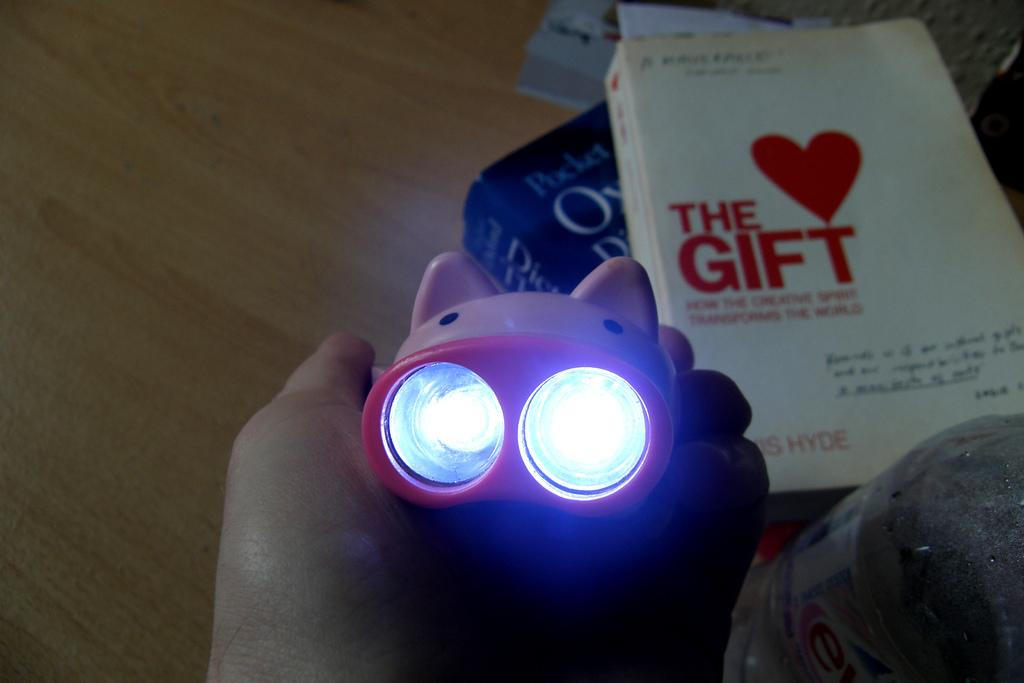What is the main structure in the image? There is a wooden platform in the image. What items are placed on the wooden platform? There are books and a bottle on the wooden platform. What is the person in the image holding? There is a person holding an object in their hand. What can be seen in the image that provides illumination? There are lights visible in the image. What type of glove is the person wearing in the image? There is no glove visible in the image; the person is holding an object in their hand, but no glove is mentioned. What color is the pencil that the person is person using to write in the image? There is no pencil present in the image; the person is holding an unspecified object in their hand. 